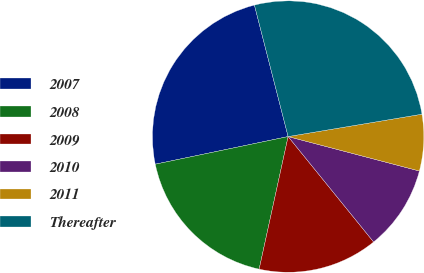Convert chart to OTSL. <chart><loc_0><loc_0><loc_500><loc_500><pie_chart><fcel>2007<fcel>2008<fcel>2009<fcel>2010<fcel>2011<fcel>Thereafter<nl><fcel>24.27%<fcel>18.31%<fcel>14.27%<fcel>10.07%<fcel>6.72%<fcel>26.36%<nl></chart> 